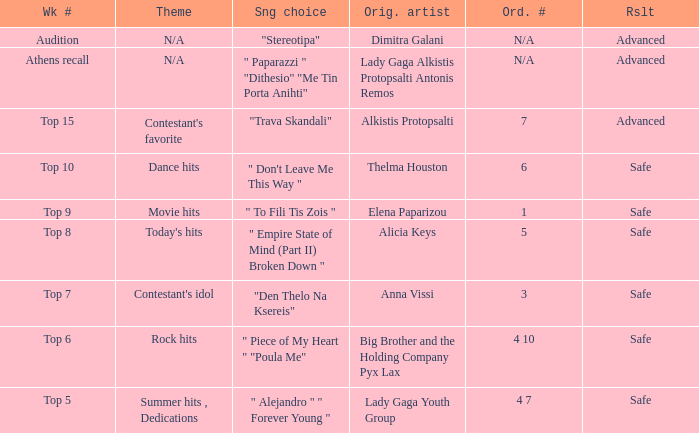Which song was chosen during the audition week? "Stereotipa". 